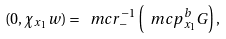<formula> <loc_0><loc_0><loc_500><loc_500>( 0 , \chi _ { x _ { 1 } } w ) = \ m c r _ { - } ^ { - 1 } \left ( \ m c p _ { x _ { 1 } } ^ { b } G \right ) ,</formula> 